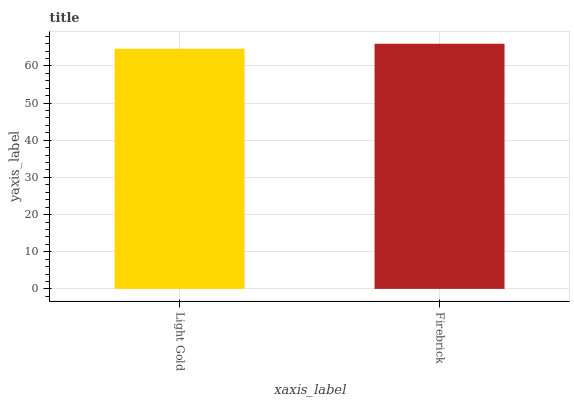Is Firebrick the minimum?
Answer yes or no. No. Is Firebrick greater than Light Gold?
Answer yes or no. Yes. Is Light Gold less than Firebrick?
Answer yes or no. Yes. Is Light Gold greater than Firebrick?
Answer yes or no. No. Is Firebrick less than Light Gold?
Answer yes or no. No. Is Firebrick the high median?
Answer yes or no. Yes. Is Light Gold the low median?
Answer yes or no. Yes. Is Light Gold the high median?
Answer yes or no. No. Is Firebrick the low median?
Answer yes or no. No. 